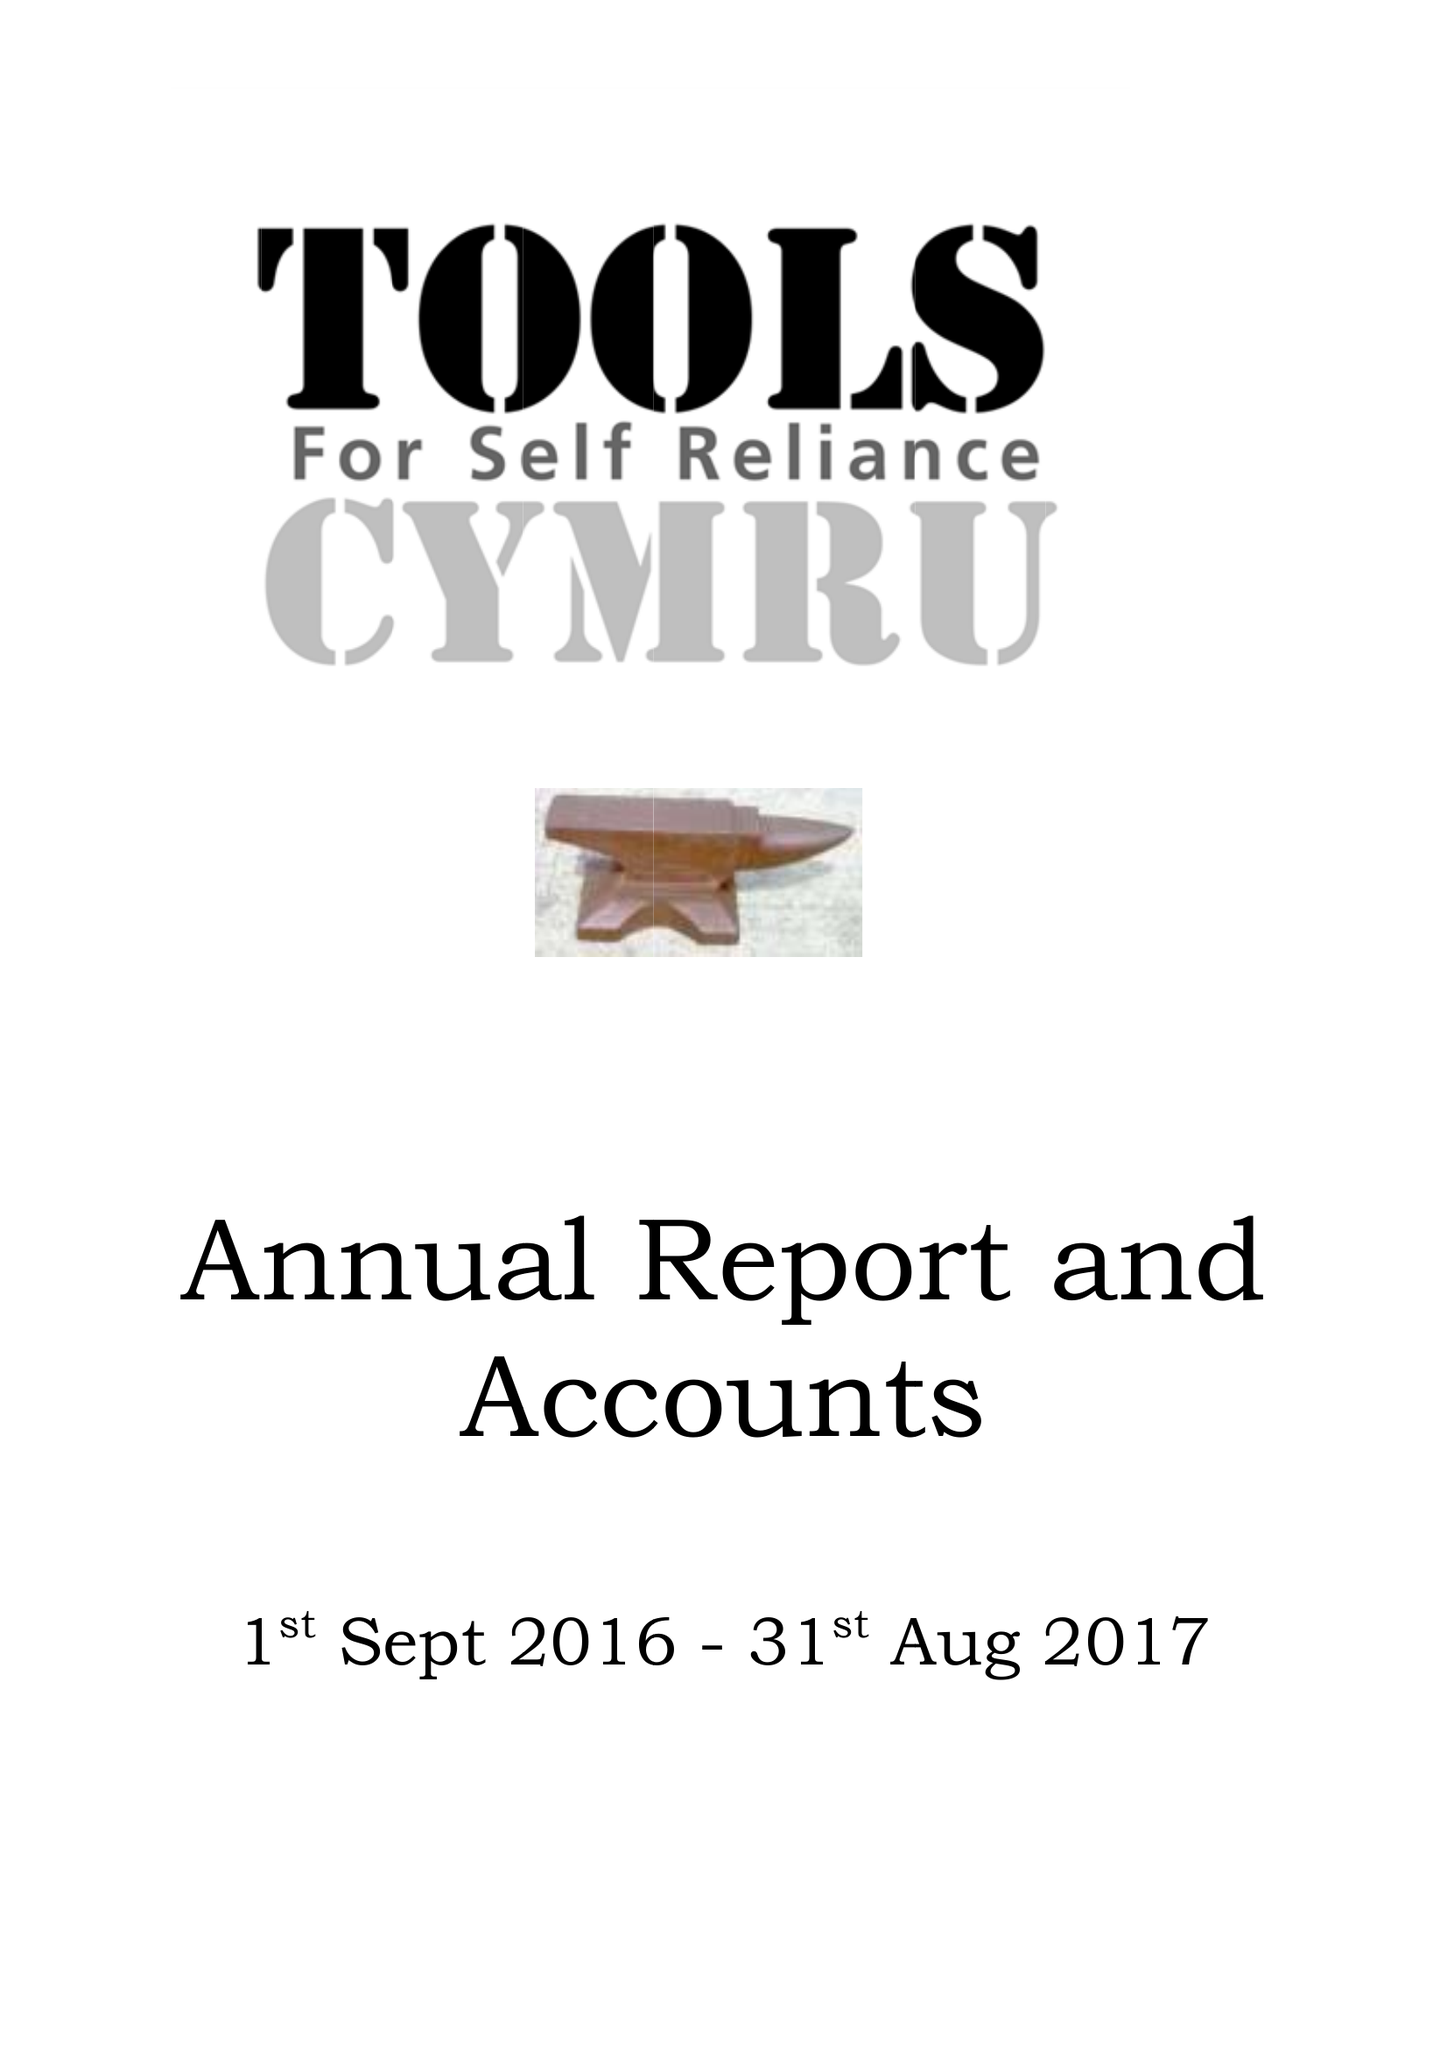What is the value for the spending_annually_in_british_pounds?
Answer the question using a single word or phrase. 140162.00 